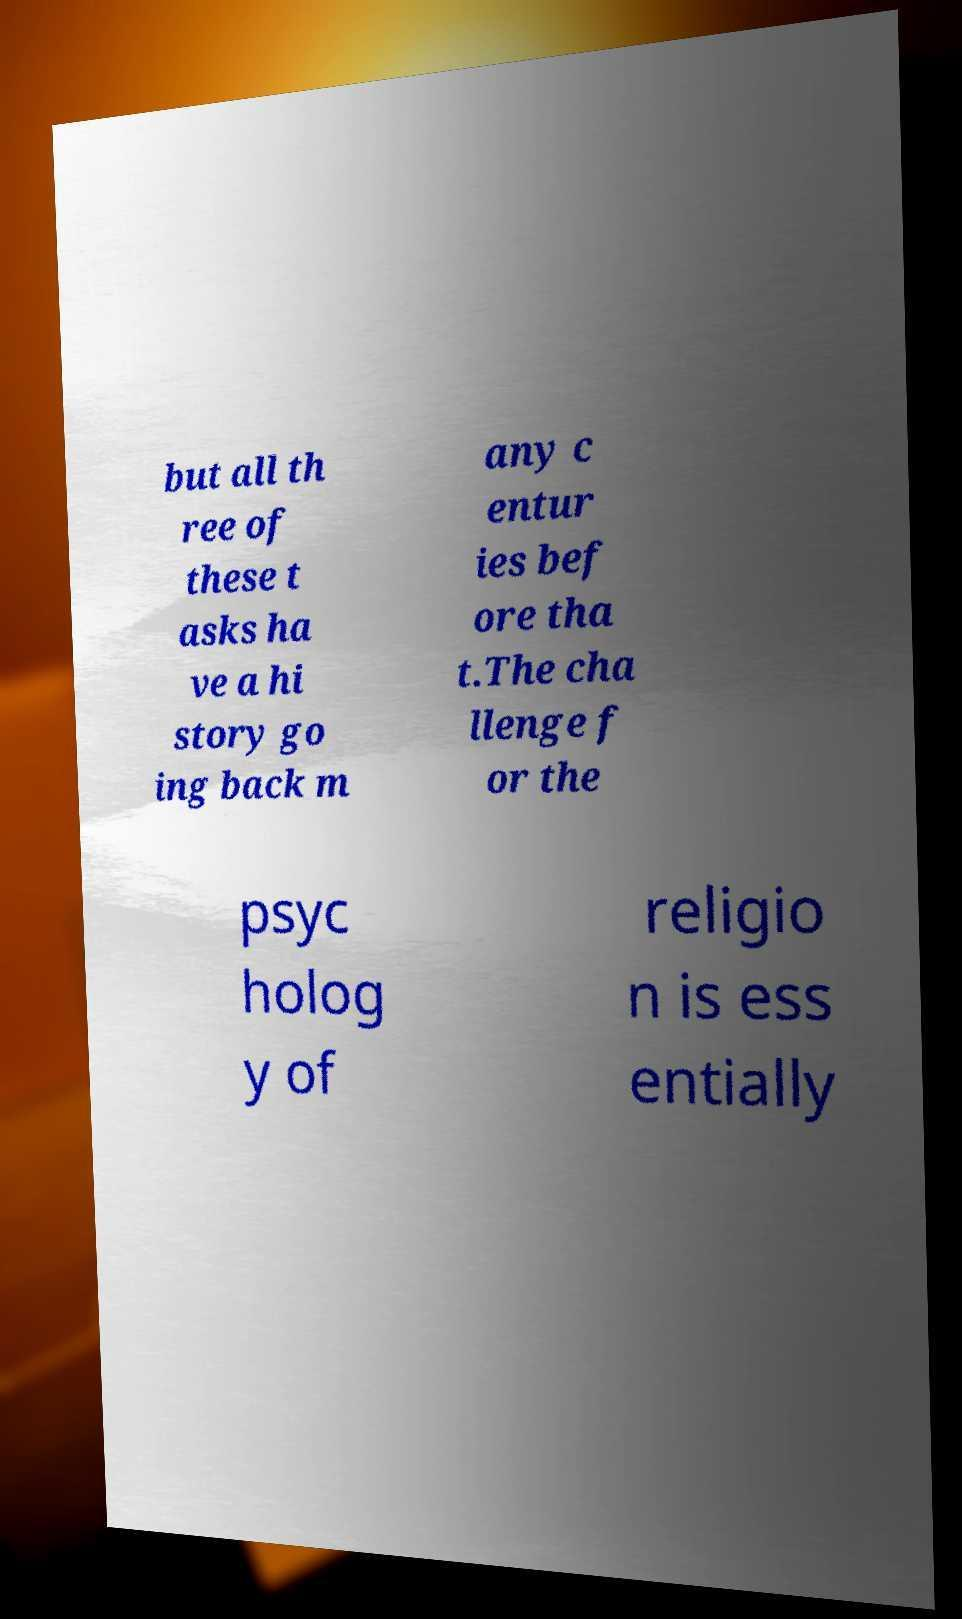Can you read and provide the text displayed in the image?This photo seems to have some interesting text. Can you extract and type it out for me? but all th ree of these t asks ha ve a hi story go ing back m any c entur ies bef ore tha t.The cha llenge f or the psyc holog y of religio n is ess entially 